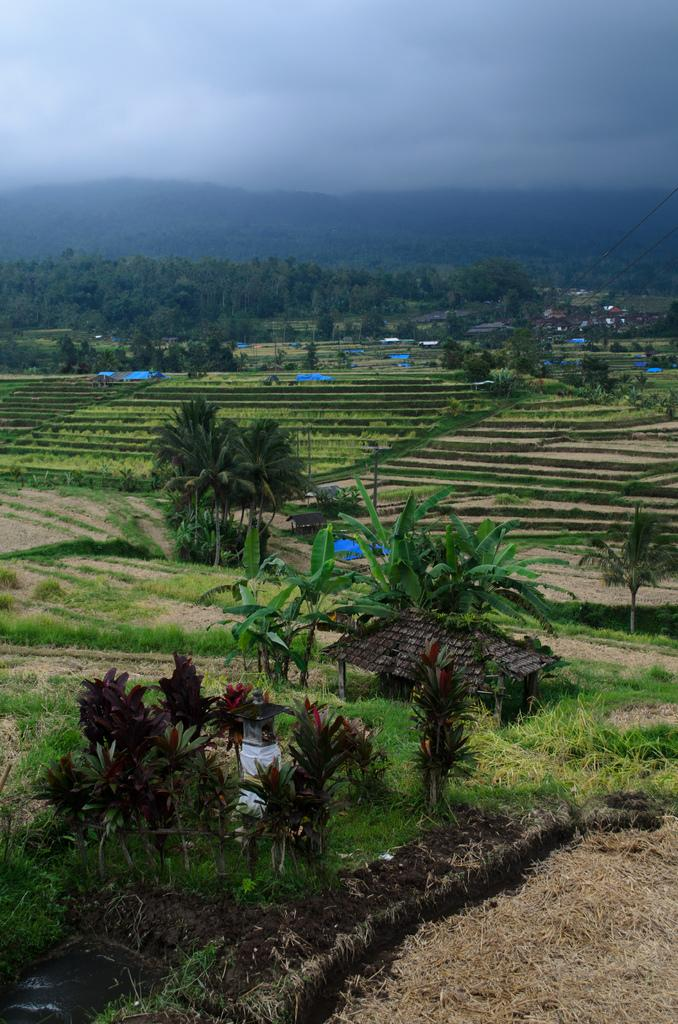What type of vegetation can be seen in the image? There is grass and plants visible in the image. What is the ground like in the image? The ground is visible in the image. What type of structures are present in the image? There are huts in the image. What can be seen in the background of the image? There is a mountain and the sky visible in the background of the image. What is the condition of the sky in the image? The sky is visible in the background of the image, and there are clouds present. What color crayon is the woman using to draw on the ring in the image? There is no woman, crayon, or ring present in the image. 